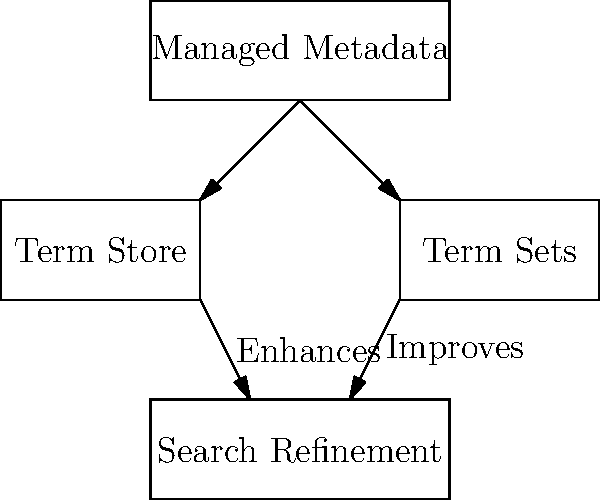In the visualization of SharePoint's managed metadata and its impact on search refinement, which component directly contributes to improving search refinement, and how many direct connections does it have to other elements in the diagram? To answer this question, let's analyze the diagram step-by-step:

1. The diagram shows four main components: Managed Metadata, Term Store, Term Sets, and Search Refinement.

2. Managed Metadata is at the top, connected to both Term Store and Term Sets.

3. Both Term Store and Term Sets have arrows pointing towards Search Refinement.

4. The arrow from Term Sets to Search Refinement is labeled "Improves", indicating a direct contribution to enhancing search refinement.

5. To count the direct connections of Term Sets:
   a. It has one incoming connection from Managed Metadata.
   b. It has one outgoing connection to Search Refinement.

6. Therefore, Term Sets directly contributes to improving search refinement and has a total of 2 direct connections to other elements in the diagram.
Answer: Term Sets; 2 connections 